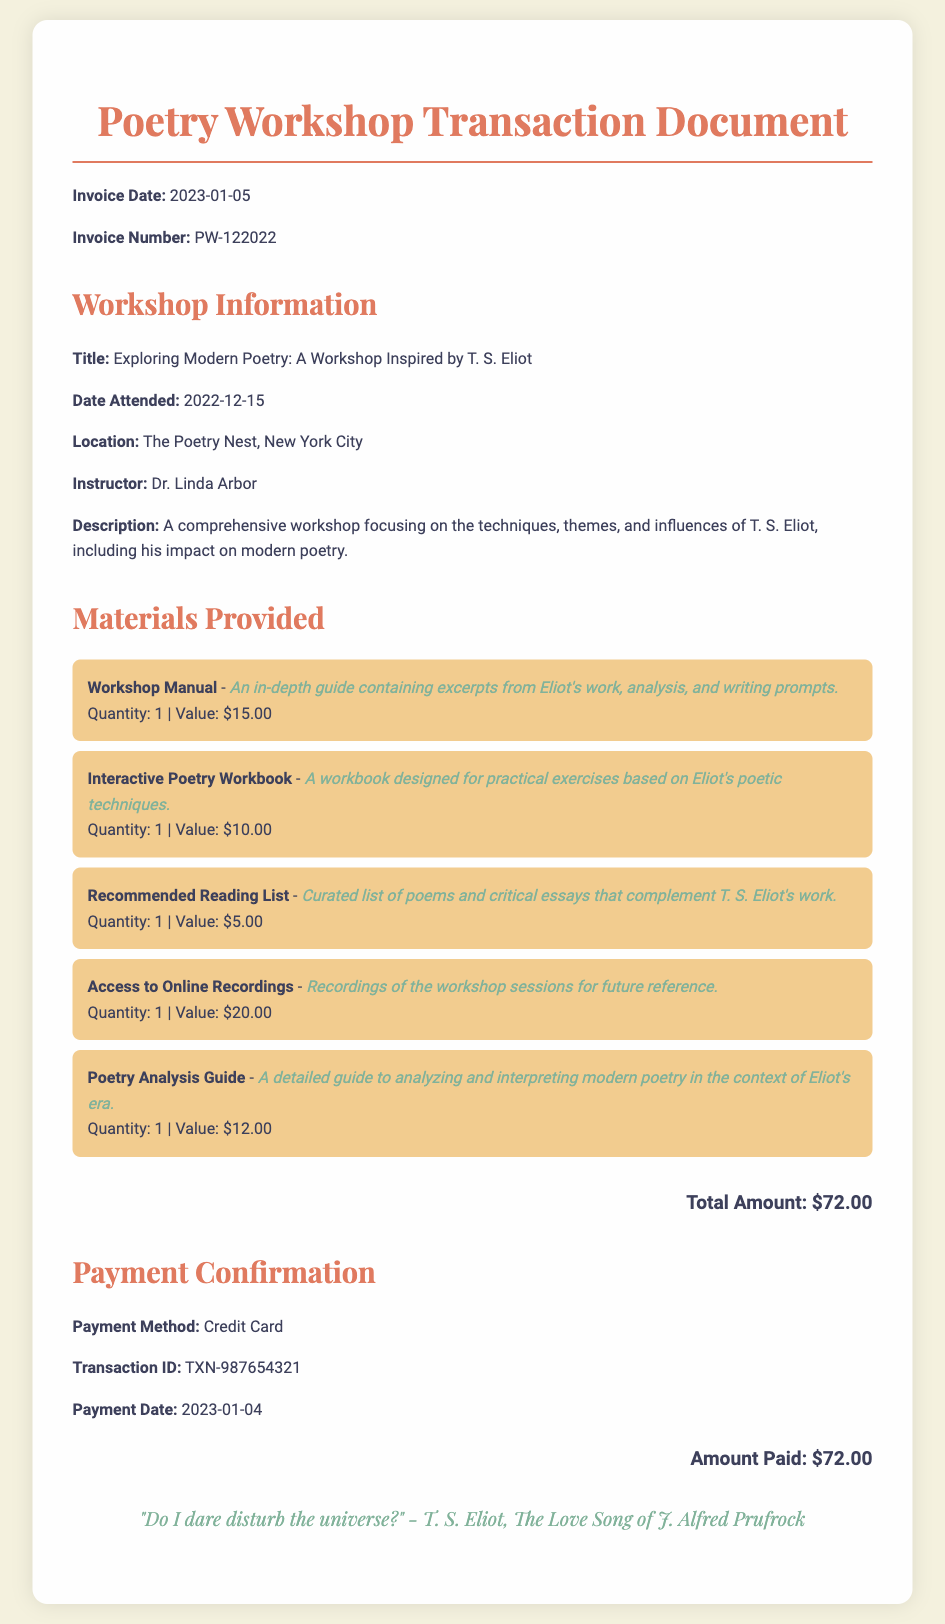What is the invoice date? The invoice date is clearly stated in the document as the date it was issued, which is January 5, 2023.
Answer: 2023-01-05 What is the title of the workshop? The title of the workshop is specified in the workshop information section, which is focused on T. S. Eliot.
Answer: Exploring Modern Poetry: A Workshop Inspired by T. S. Eliot How much was paid for the workshop? The amount paid is outlined under the payment confirmation section, indicating the total that was charged.
Answer: $72.00 Who was the instructor for the workshop? The name of the instructor is mentioned in the workshop details section.
Answer: Dr. Linda Arbor What kind of payment method was used? The type of payment method is provided under the payment confirmation section, indicating how the payment was processed.
Answer: Credit Card What is the quantity of the Workshop Manual provided? The document lists the quantity for each material provided, stating the count for the Workshop Manual specifically.
Answer: 1 Calculate the total value of all the materials provided. The total value is calculated by adding up the values for each material listed, which totals $72.00.
Answer: $72.00 What is the transaction ID for the payment? The transaction ID is detailed in the payment confirmation section, representing the unique identifier for this transaction.
Answer: TXN-987654321 What is the date when the workshop was attended? The date attended is specified in the workshop information section as the day the workshop took place.
Answer: 2022-12-15 